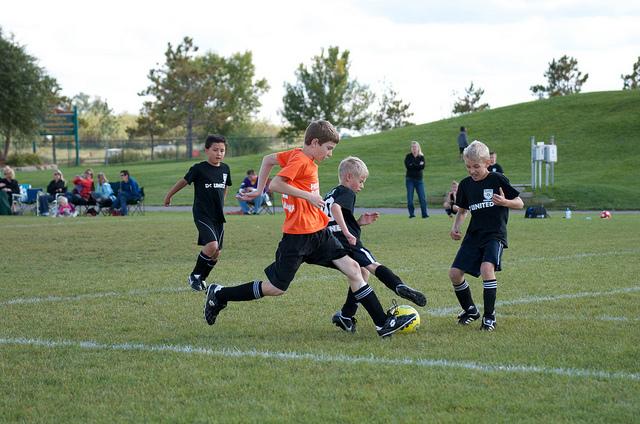What color is the man in the middle's shoes?
Be succinct. Black. How many kids are wearing orange shirts?
Keep it brief. 1. Is anyone watching their game?
Answer briefly. Yes. What color is the ball?
Quick response, please. Yellow. Is this a boy or girl?
Concise answer only. Boy. Are these two soccer teams playing in a tournament?
Give a very brief answer. Yes. What hairstyle is the boy on the left sporting?
Be succinct. Short. What are they playing?
Keep it brief. Soccer. Is there a concession stand?
Give a very brief answer. No. What sport is being played?
Be succinct. Soccer. What color is the grass?
Quick response, please. Green. 